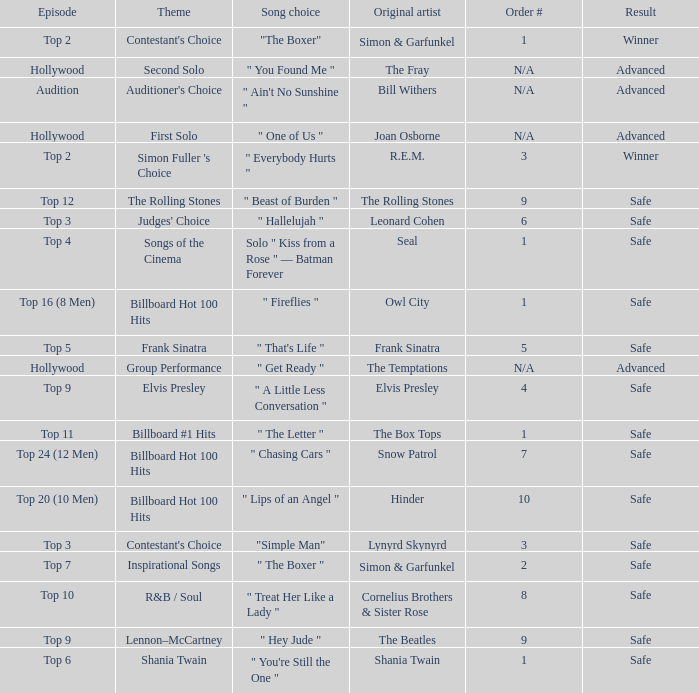The theme Auditioner's Choice	has what song choice? " Ain't No Sunshine ". 